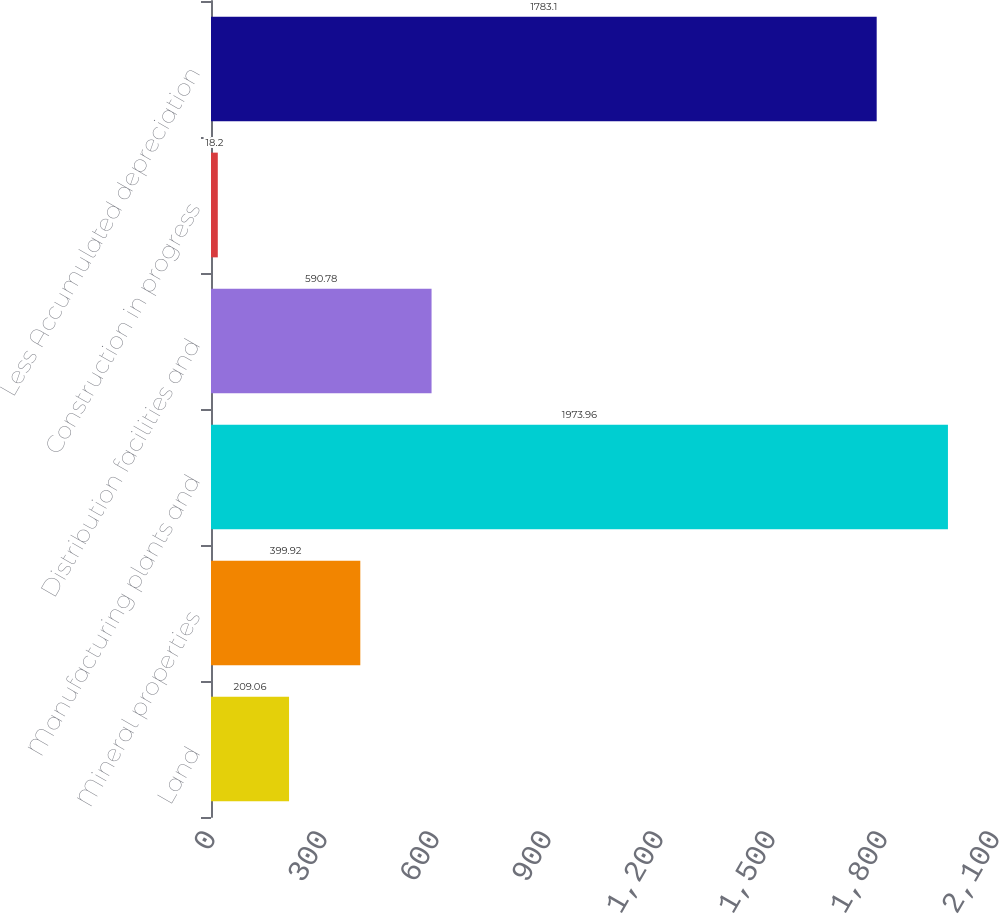Convert chart. <chart><loc_0><loc_0><loc_500><loc_500><bar_chart><fcel>Land<fcel>Mineral properties<fcel>Manufacturing plants and<fcel>Distribution facilities and<fcel>Construction in progress<fcel>Less Accumulated depreciation<nl><fcel>209.06<fcel>399.92<fcel>1973.96<fcel>590.78<fcel>18.2<fcel>1783.1<nl></chart> 